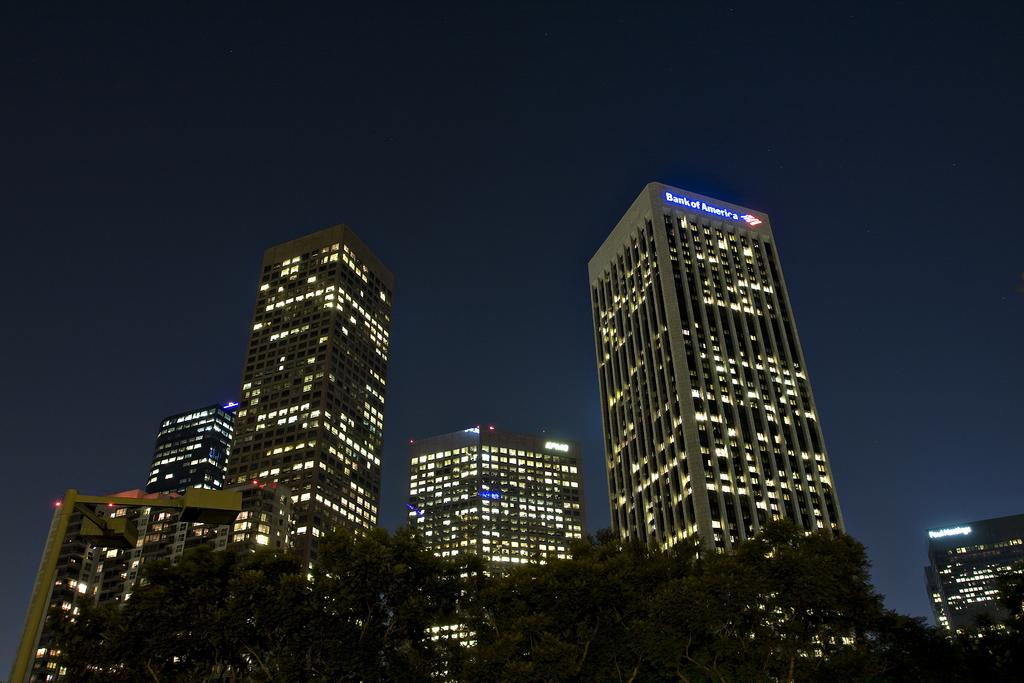What type of natural elements can be seen in the image? There are trees in the image. What type of man-made structures are present in the image? There are buildings in the image. What type of illumination is visible in the image? There are lights in the image. What is the price of the alarm system in the image? There is no alarm system present in the image, so it is not possible to determine its price. 